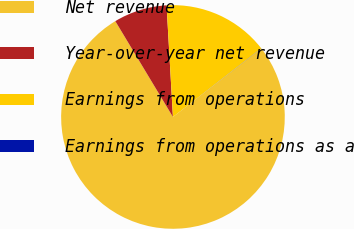Convert chart. <chart><loc_0><loc_0><loc_500><loc_500><pie_chart><fcel>Net revenue<fcel>Year-over-year net revenue<fcel>Earnings from operations<fcel>Earnings from operations as a<nl><fcel>76.88%<fcel>7.71%<fcel>15.39%<fcel>0.02%<nl></chart> 